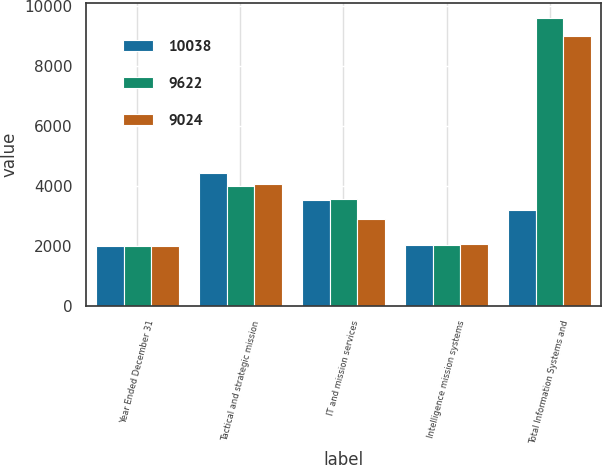<chart> <loc_0><loc_0><loc_500><loc_500><stacked_bar_chart><ecel><fcel>Year Ended December 31<fcel>Tactical and strategic mission<fcel>IT and mission services<fcel>Intelligence mission systems<fcel>Total Information Systems and<nl><fcel>10038<fcel>2008<fcel>4455<fcel>3536<fcel>2047<fcel>3215<nl><fcel>9622<fcel>2007<fcel>4008<fcel>3584<fcel>2030<fcel>9622<nl><fcel>9024<fcel>2006<fcel>4063<fcel>2894<fcel>2067<fcel>9024<nl></chart> 